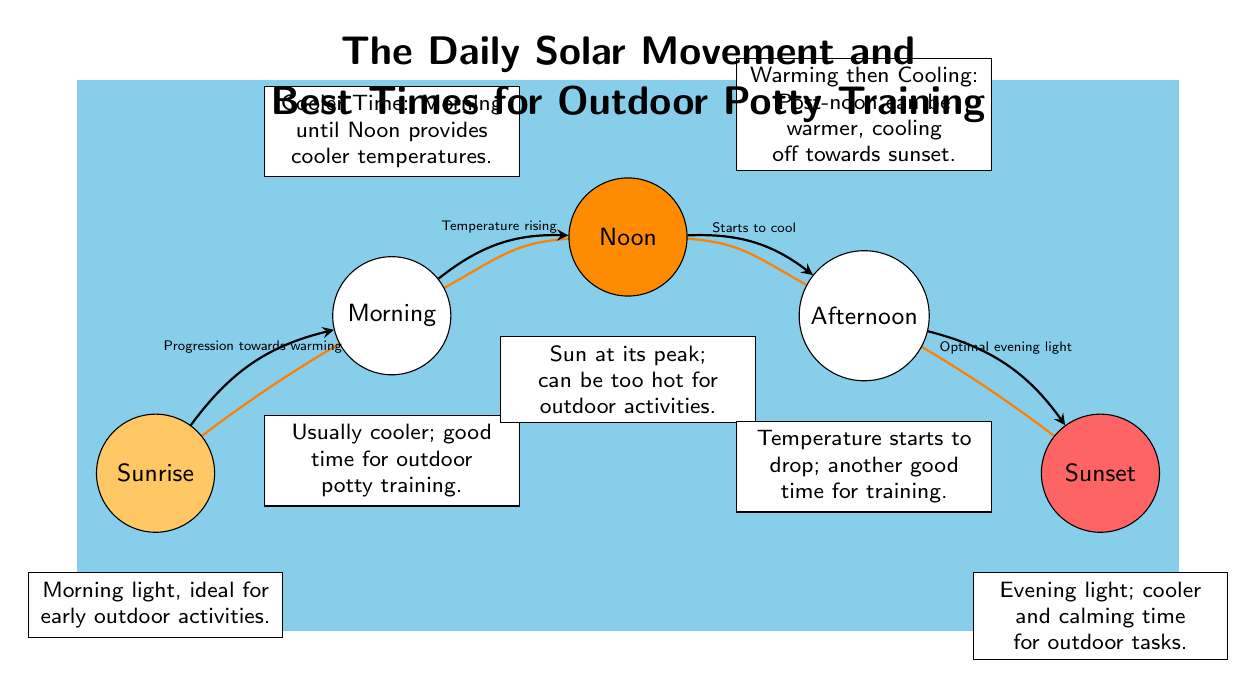What is the color representing noon on the diagram? The node labeled "Noon" uses the color defined as "nooncolor." Referring to the color scheme in the diagram, "nooncolor" is specified as RGB (255, 140, 0), which is an orange shade.
Answer: orange How many main time events are represented in the diagram? The diagram includes five main time events: Sunrise, Morning, Noon, Afternoon, and Sunset. By counting the labeled events, we confirm there are five.
Answer: five What visual cue indicates the progression of warming from sunrise to noon? The arc from "Sunrise" to "Morning", and then from "Morning" to "Noon" indicates that the sun's position progresses and temperatures rise. The arrows clearly show this progression towards warming visually.
Answer: progression towards warming Which time is marked as "ideal for early outdoor activities"? The note below the "Sunrise" node indicates that this time is ideal for early outdoor activities, as it mentions the benefits of morning light for these tasks.
Answer: Sunrise What does the diagram suggest about outdoor potty training in the afternoon? The note under "Afternoon" indicates it's a good time for training, specifically stating that the temperature starts to drop after noon, making it more comfortable for outdoor activities.
Answer: good time for training Which time is described as having "Sun at its peak"? The note located below the "Noon" node describes this time, emphasizing that at noon, the sun is at its highest position and temperatures can be too hot for outdoor activities.
Answer: Noon What is the main color used to depict sunset in the diagram? The node labeled "Sunset" is filled with the color "sunsetcolor," which is specified as RGB (255, 100, 100), indicating a red color that represents sunset visually in the diagram.
Answer: sunsetcolor When does the diagram suggest the best time to perform outdoor activities, cooler and calming? The note below the "Sunset" node states that evening light is cooler and calming, suggesting that this time is preferable for outdoor activities like potty training.
Answer: Sunset What is a key factor affecting outdoor potty training from noon to sunset? The diagram notes that post-noon it can be warmer, but temperatures begin cooling off towards sunset. This implies that training sessions should consider the heat of the day.
Answer: warming then cooling 